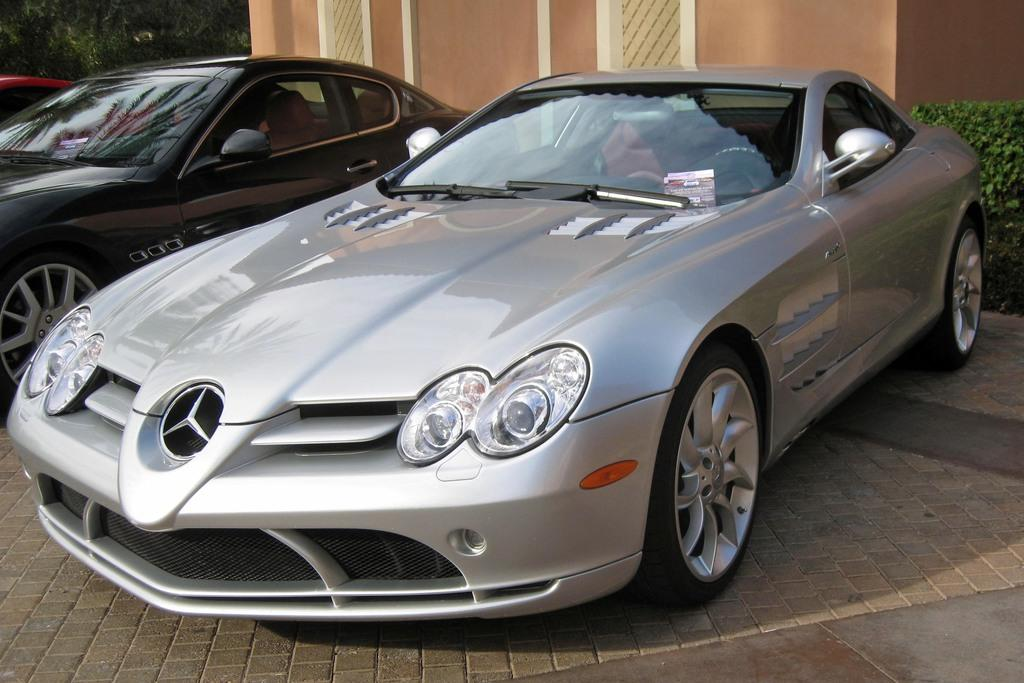What can be seen in the foreground of the image? There are cars in the foreground of the image. What is located on the right side of the image? There is a plant on the right side of the image. What type of vegetation is on the left side of the image? There are trees on the left side of the image. What structure is visible in the center of the background of the image? There is a building in the center of the background of the image. What is the weight of the snake in the image? There is no snake present in the image, so its weight cannot be determined. What nation is represented by the flag in the image? There is no flag present in the image, so it is not possible to determine which nation is represented. 